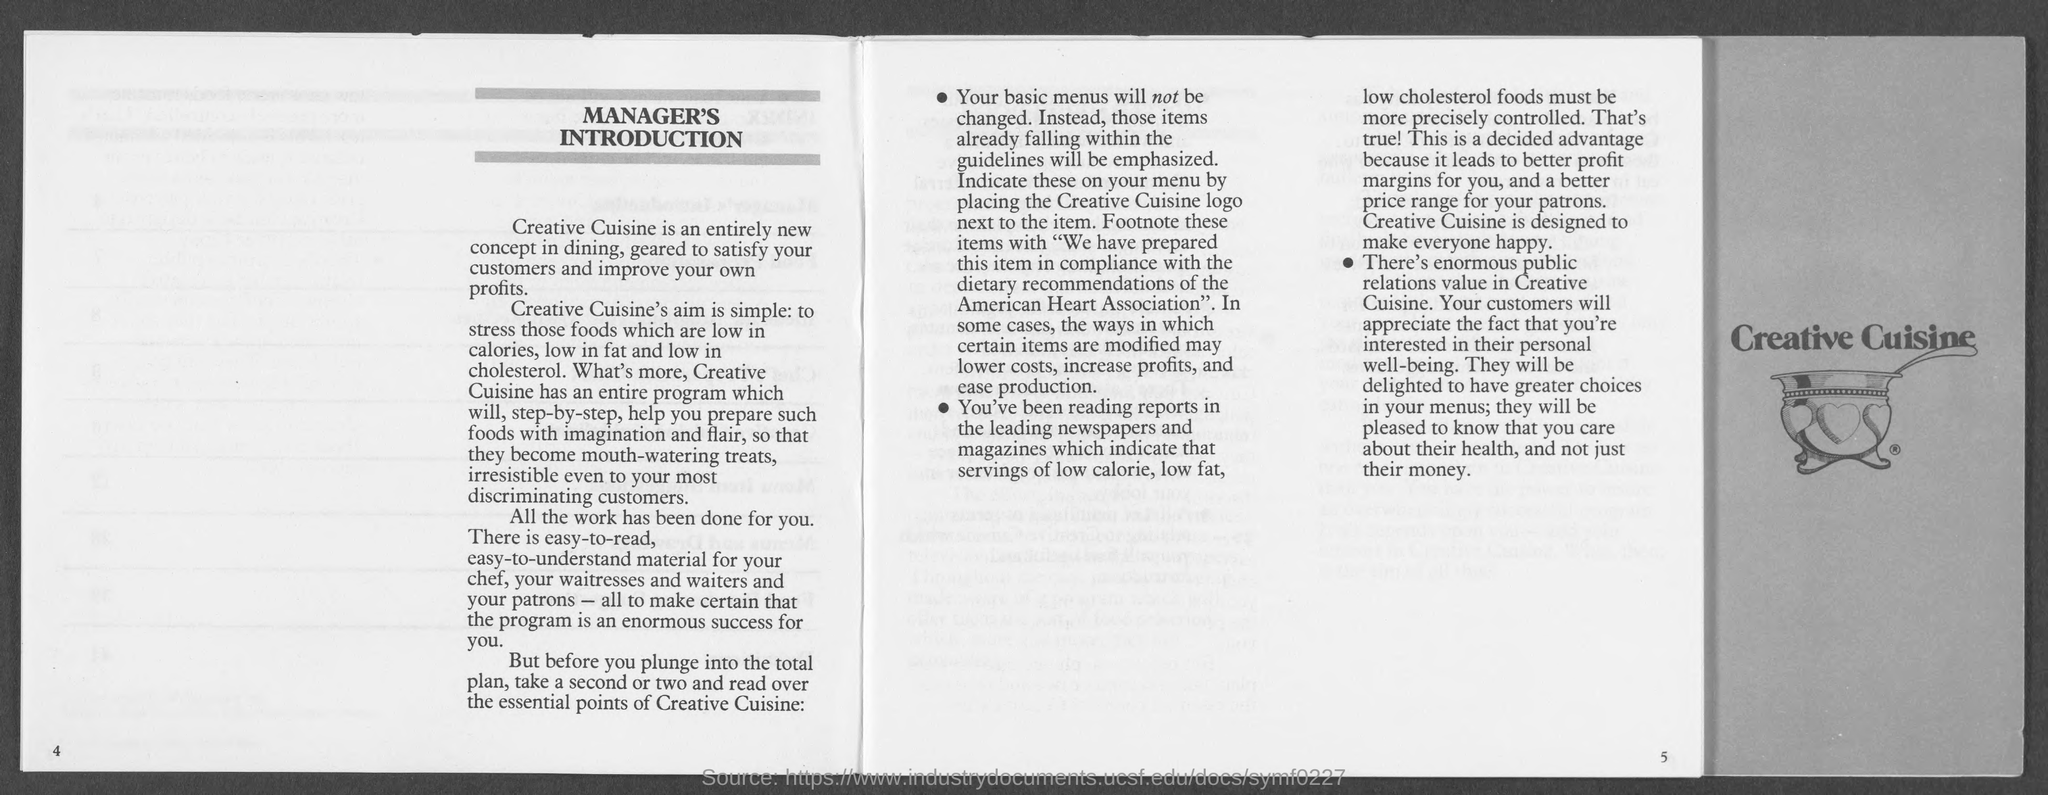List a handful of essential elements in this visual. The American Heart Association is associated with dietary recommendations. 